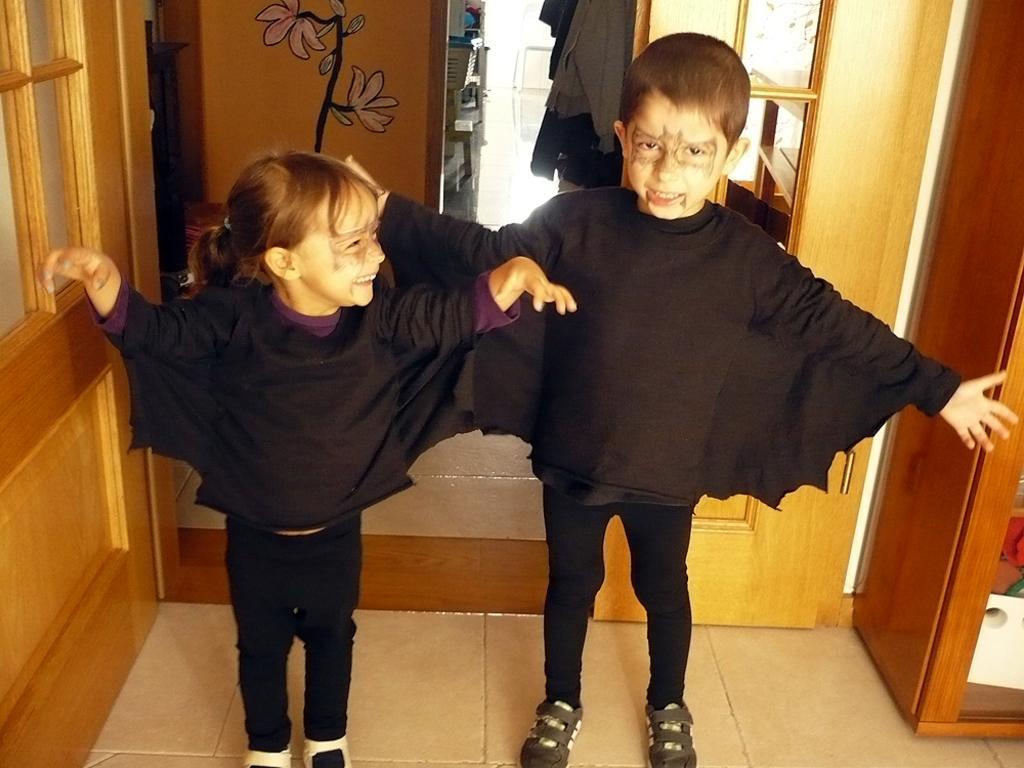Could you give a brief overview of what you see in this image? In this picture there is a girl who is wearing black dress, besides her there is a boy who is wearing black dress and shoes. Both of them were smiling. In the back I can see the person who is standing near to the shelf. On that I can see some objects. On the left there is a door. On the right I can see some objects on the cupboard. 